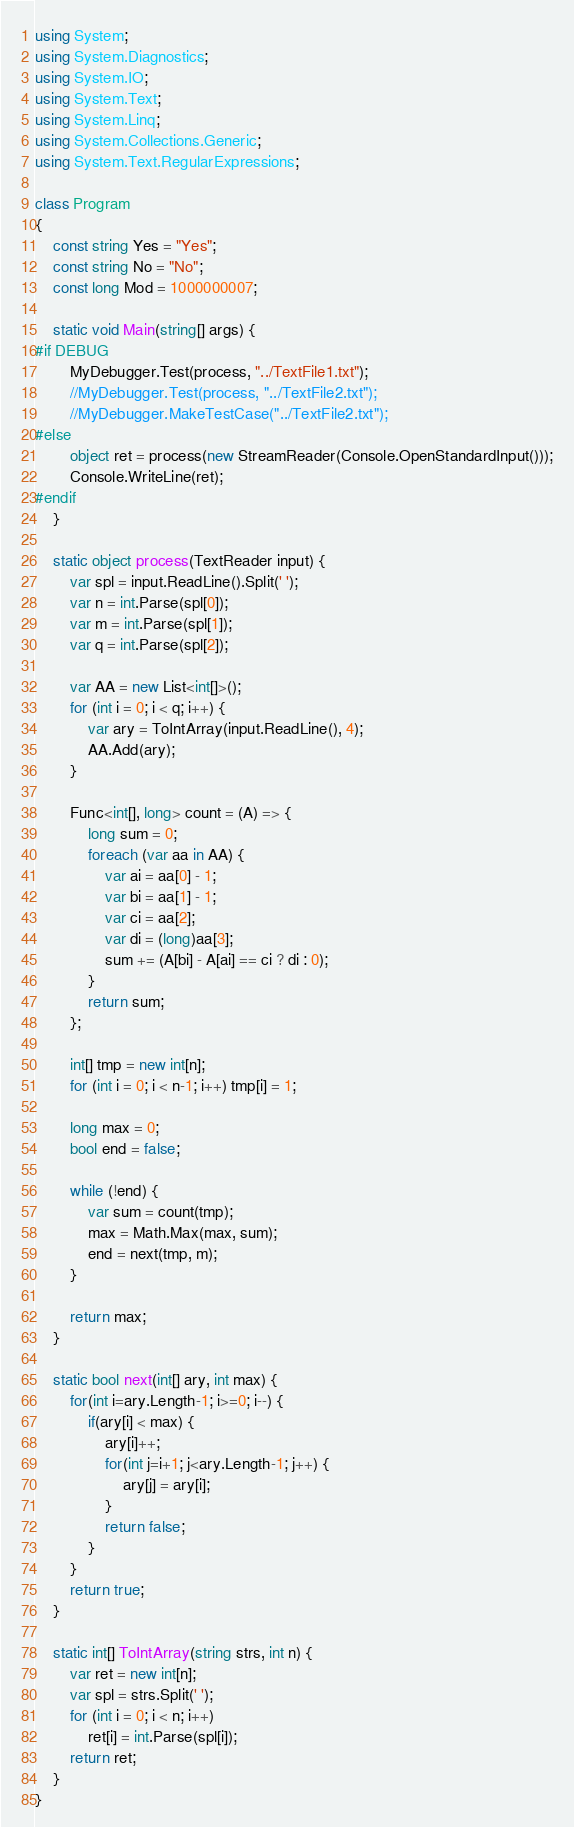Convert code to text. <code><loc_0><loc_0><loc_500><loc_500><_C#_>using System;
using System.Diagnostics;
using System.IO;
using System.Text;
using System.Linq;
using System.Collections.Generic;
using System.Text.RegularExpressions;

class Program
{
    const string Yes = "Yes";
    const string No = "No";
    const long Mod = 1000000007;

    static void Main(string[] args) {
#if DEBUG
        MyDebugger.Test(process, "../TextFile1.txt");
        //MyDebugger.Test(process, "../TextFile2.txt");
        //MyDebugger.MakeTestCase("../TextFile2.txt");
#else
        object ret = process(new StreamReader(Console.OpenStandardInput()));
        Console.WriteLine(ret);
#endif
    }

    static object process(TextReader input) {
        var spl = input.ReadLine().Split(' ');
        var n = int.Parse(spl[0]);
        var m = int.Parse(spl[1]);
        var q = int.Parse(spl[2]);

        var AA = new List<int[]>();
        for (int i = 0; i < q; i++) {
            var ary = ToIntArray(input.ReadLine(), 4);
            AA.Add(ary);
        }

        Func<int[], long> count = (A) => {
            long sum = 0;
            foreach (var aa in AA) {
                var ai = aa[0] - 1;
                var bi = aa[1] - 1;
                var ci = aa[2];
                var di = (long)aa[3];
                sum += (A[bi] - A[ai] == ci ? di : 0);
            }
            return sum;
        };

        int[] tmp = new int[n];
        for (int i = 0; i < n-1; i++) tmp[i] = 1;

        long max = 0;
        bool end = false;

        while (!end) {
            var sum = count(tmp);
            max = Math.Max(max, sum);
            end = next(tmp, m);
        }

        return max;
    }

    static bool next(int[] ary, int max) {
        for(int i=ary.Length-1; i>=0; i--) {
            if(ary[i] < max) {
                ary[i]++;
                for(int j=i+1; j<ary.Length-1; j++) {
                    ary[j] = ary[i];
                }
                return false;
            }
        }
        return true;
    }

    static int[] ToIntArray(string strs, int n) {
        var ret = new int[n];
        var spl = strs.Split(' ');
        for (int i = 0; i < n; i++)
            ret[i] = int.Parse(spl[i]);
        return ret;
    }
}
</code> 